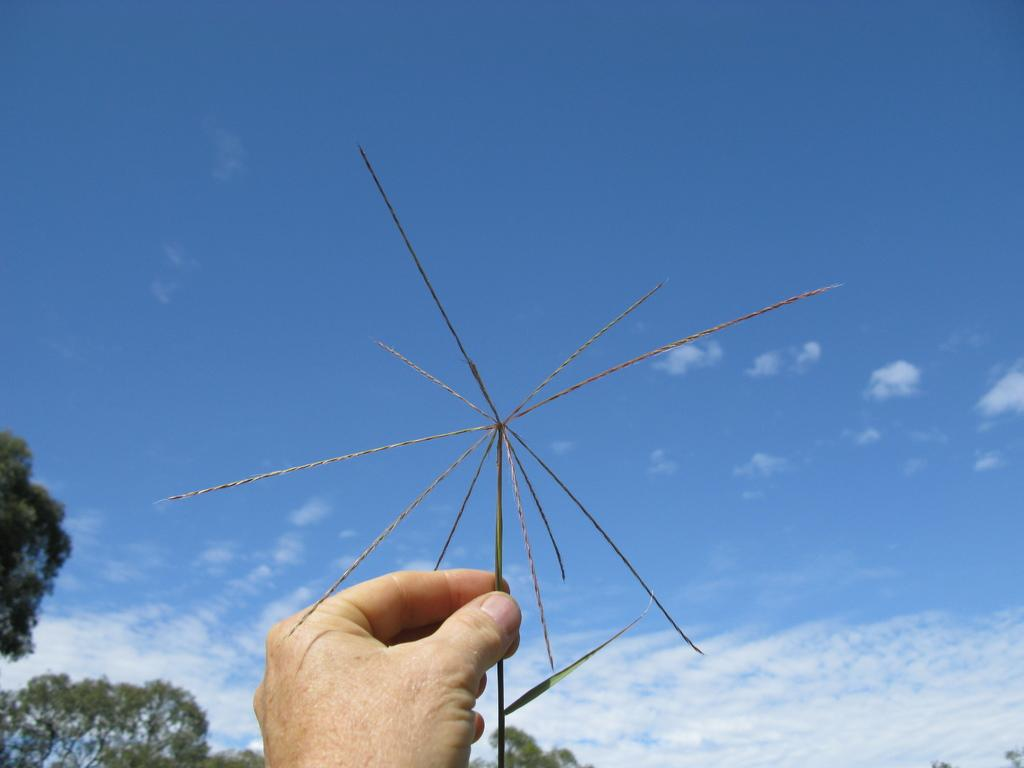What is the main subject of the image? The main subject of the image is a hand. What is the hand holding? The hand is holding grass. What can be seen in the background of the image? There are trees in the background of the image. What is visible at the top of the image? The sky is visible at the top of the image. What type of sofa can be seen in the image? There is no sofa present in the image. How does the hand represent society in the image? The image does not depict the hand as a representative of society; it simply shows a hand holding grass. 